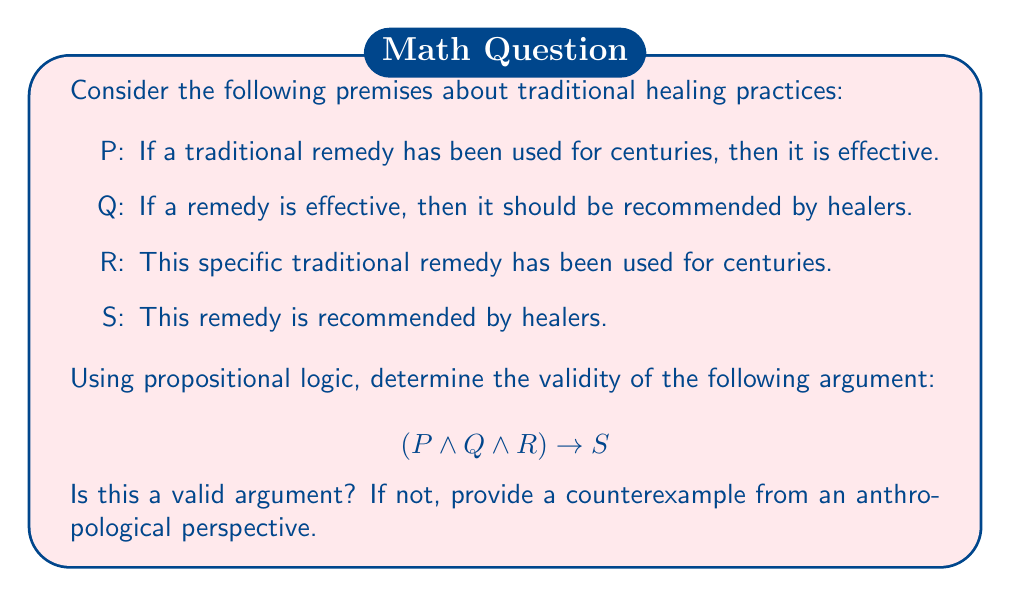Show me your answer to this math problem. To determine the validity of this argument, we need to examine the logical structure and evaluate if the conclusion (S) necessarily follows from the premises (P, Q, and R).

Let's break down the premises:
1. $P: C \rightarrow E$ (where C: used for centuries, E: effective)
2. $Q: E \rightarrow H$ (where H: recommended by healers)
3. $R: C$ (this remedy has been used for centuries)

The argument claims: $(P \land Q \land R) \rightarrow S$

To prove this is valid, we need to show that S (the remedy is recommended by healers) necessarily follows from the conjunction of P, Q, and R.

Step 1: From R, we know C is true.
Step 2: From P and C, we can deduce E (Modus Ponens).
Step 3: From Q and E, we can deduce H (Modus Ponens).

Therefore, we have logically arrived at H, which is equivalent to S in our original statement.

However, from an anthropological perspective, this argument may not always hold true in real-world scenarios. While the logic is valid, the premises themselves may be questioned:

1. The assumption that longevity of use guarantees effectiveness (P) is not always true. Many traditional practices persist due to cultural factors rather than efficacy.
2. The premise that all effective remedies are recommended by healers (Q) may not account for variations in healing traditions or the incorporation of new knowledge.

A potential counterexample could be a traditional remedy that has been used for centuries (satisfying R) but has been found ineffective through modern scientific testing. In this case, ethical healers might not recommend it despite its long history of use.

This example highlights the importance of critically examining the premises in arguments about traditional healing practices, even when the logical structure appears valid.
Answer: The argument is logically valid, as the conclusion S necessarily follows from the premises P, Q, and R using propositional logic. However, from an anthropological perspective, the premises themselves may be questionable, and real-world scenarios could provide counterexamples that challenge the argument's practical application. 